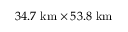Convert formula to latex. <formula><loc_0><loc_0><loc_500><loc_500>3 4 . 7 k m \times 5 3 . 8 k m</formula> 